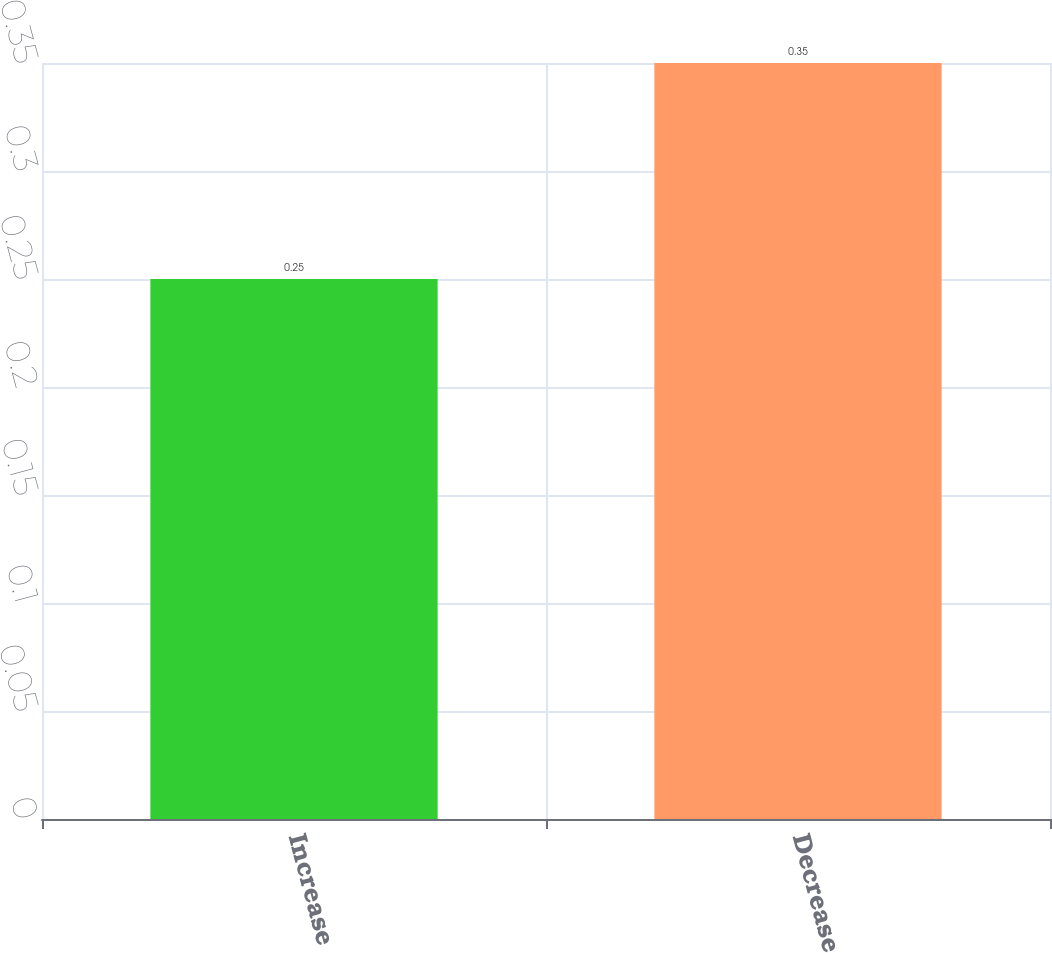<chart> <loc_0><loc_0><loc_500><loc_500><bar_chart><fcel>Increase<fcel>Decrease<nl><fcel>0.25<fcel>0.35<nl></chart> 